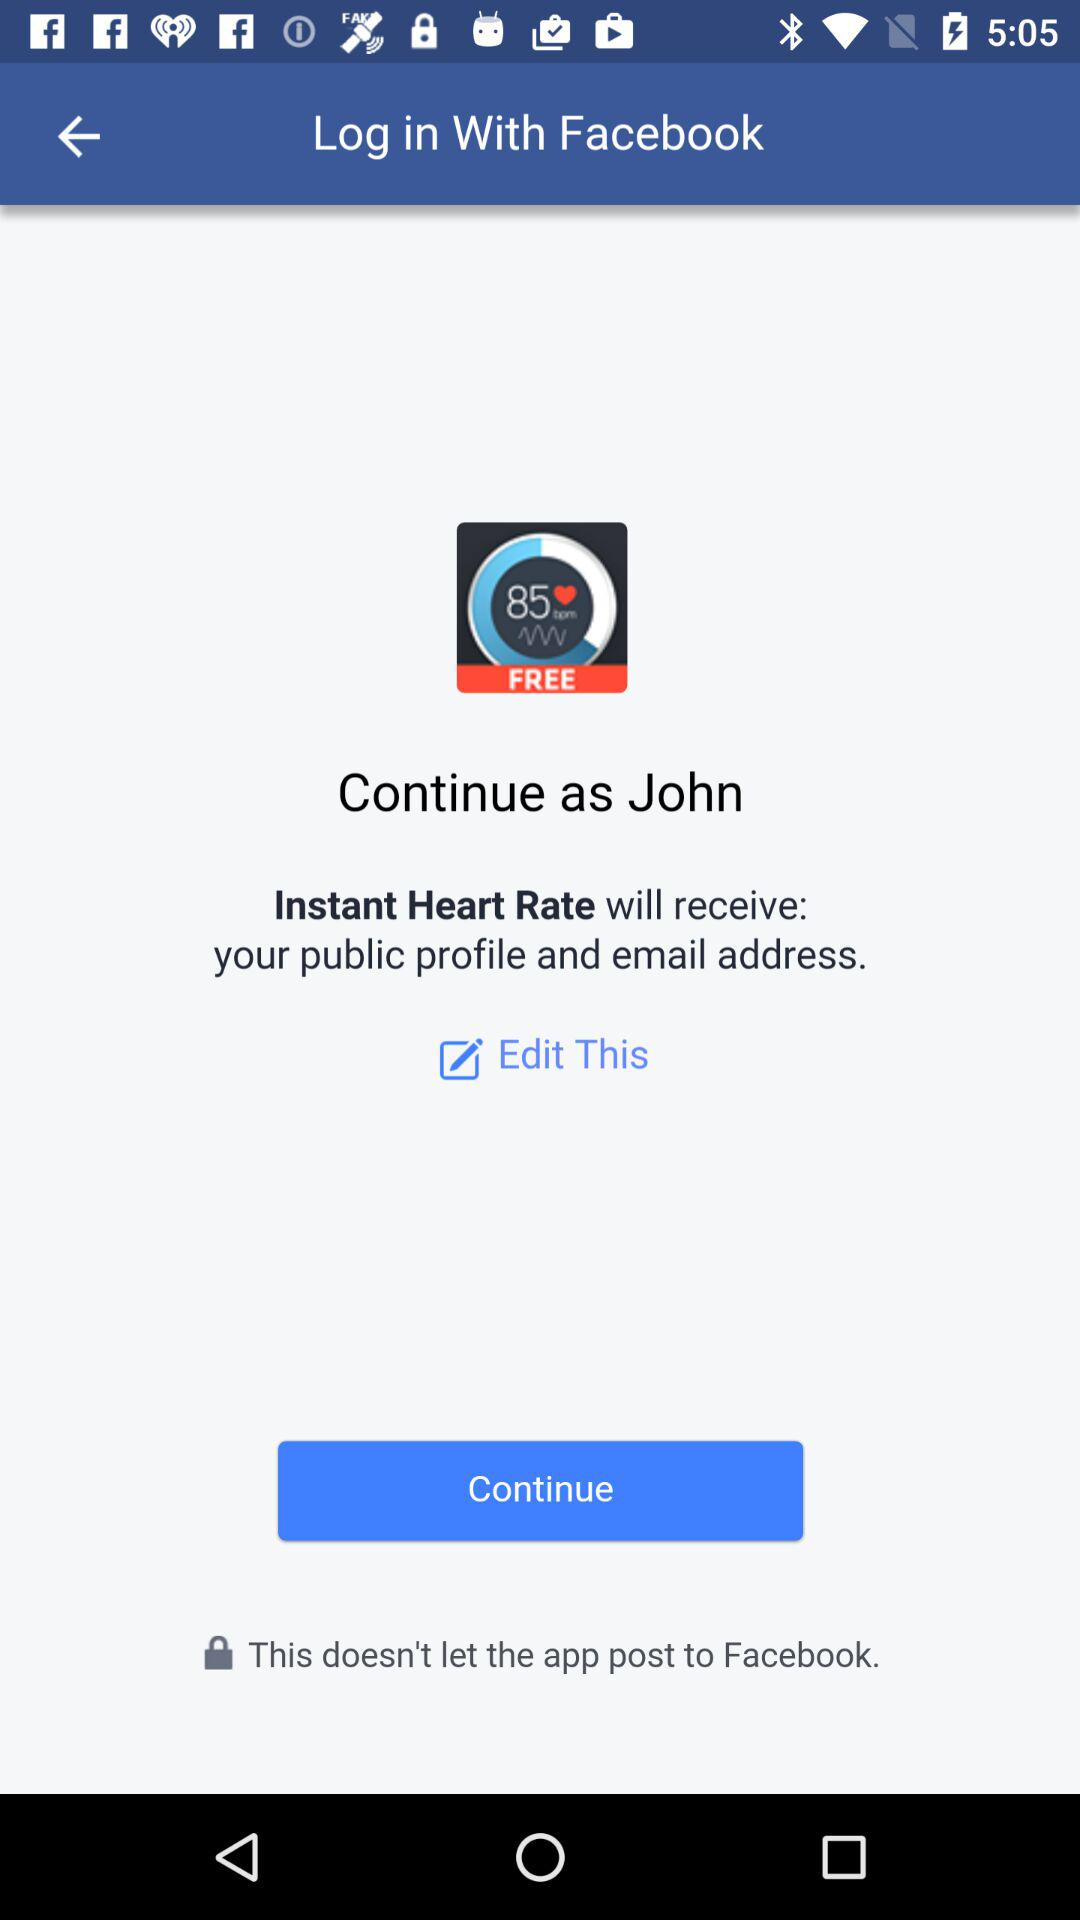What application is asking for permission? The application asking for permission is "Instant Heart Rate". 